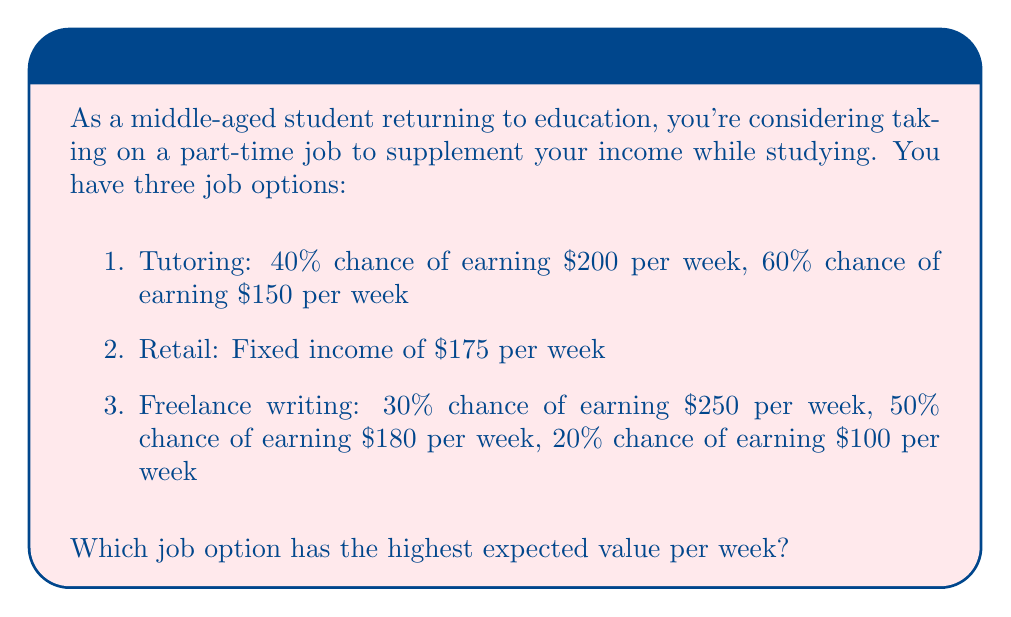Can you answer this question? To solve this problem, we need to calculate the expected value for each job option and compare them.

1. Tutoring:
The expected value is calculated by multiplying each possible outcome by its probability and then summing these products.

$$ EV_{tutoring} = (0.40 \times \$200) + (0.60 \times \$150) $$
$$ EV_{tutoring} = \$80 + \$90 = \$170 $$

2. Retail:
This is a fixed income, so the expected value is simply the stated amount.

$$ EV_{retail} = \$175 $$

3. Freelance writing:
We apply the same method as for tutoring, but with three possible outcomes.

$$ EV_{freelance} = (0.30 \times \$250) + (0.50 \times \$180) + (0.20 \times \$100) $$
$$ EV_{freelance} = \$75 + \$90 + \$20 = \$185 $$

Comparing the expected values:
$$ EV_{tutoring} = \$170 $$
$$ EV_{retail} = \$175 $$
$$ EV_{freelance} = \$185 $$

The freelance writing option has the highest expected value at $185 per week.
Answer: The job option with the highest expected value is freelance writing, with an expected value of $185 per week. 